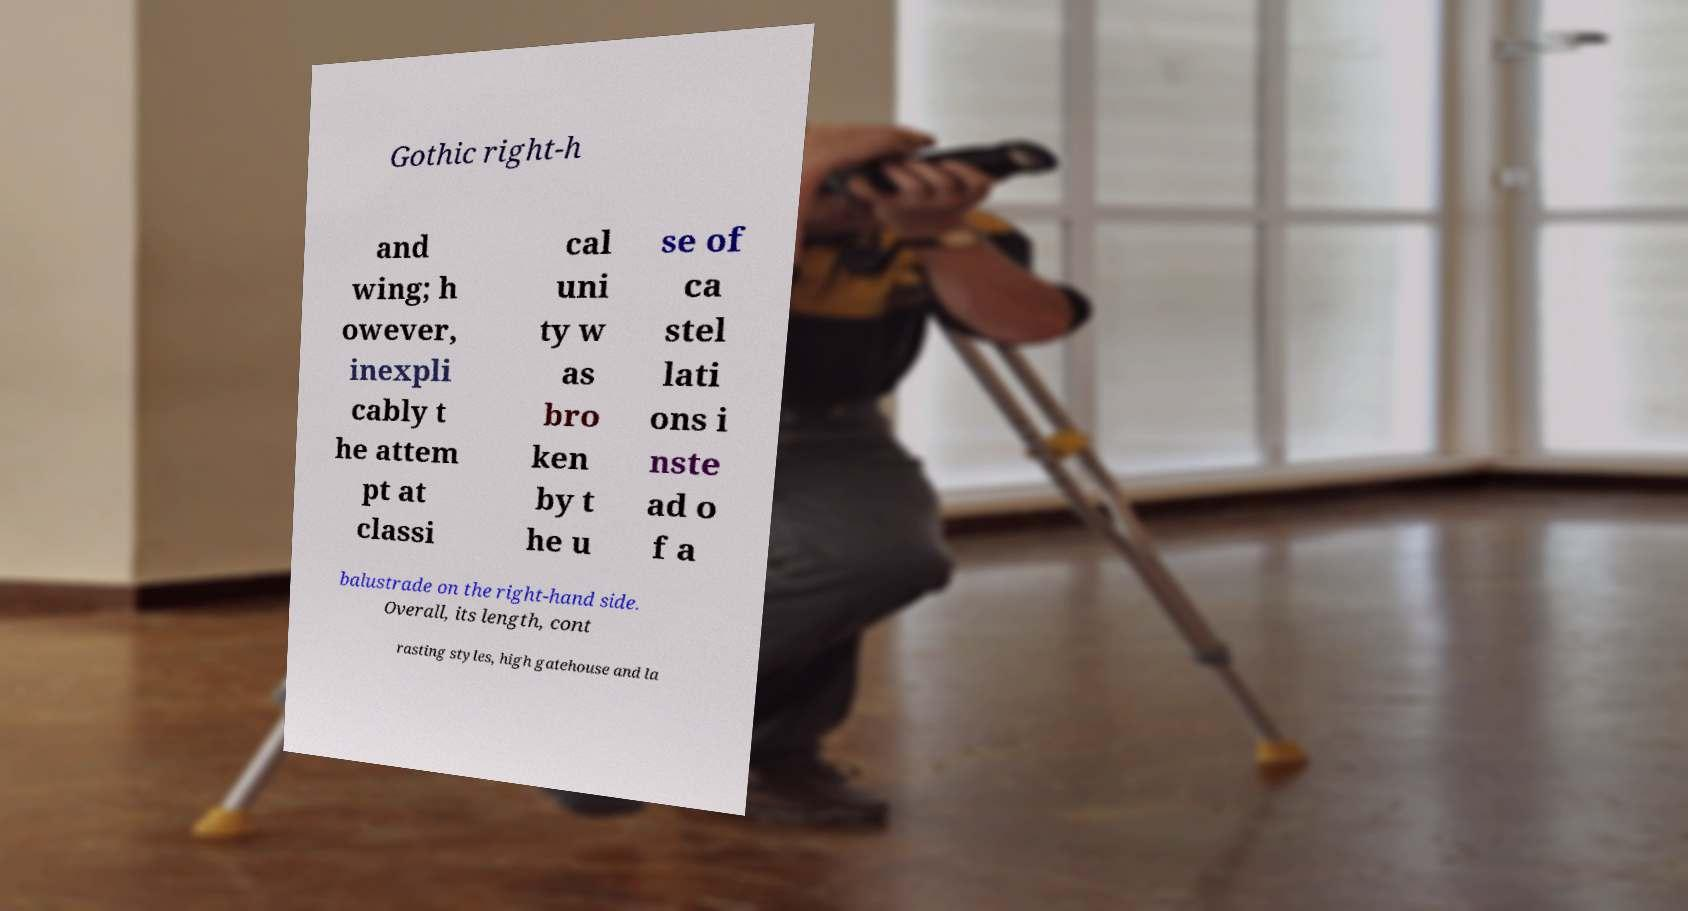Please identify and transcribe the text found in this image. Gothic right-h and wing; h owever, inexpli cably t he attem pt at classi cal uni ty w as bro ken by t he u se of ca stel lati ons i nste ad o f a balustrade on the right-hand side. Overall, its length, cont rasting styles, high gatehouse and la 